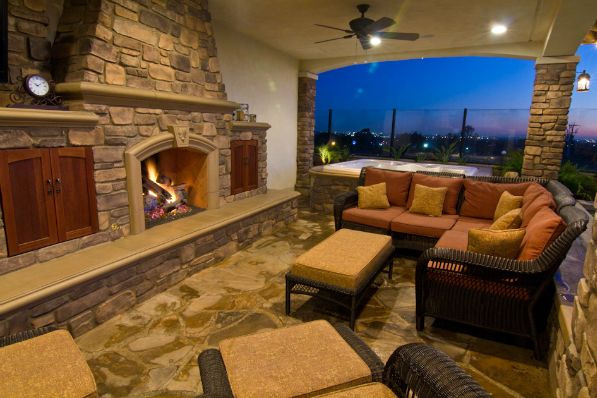How many people are in the room? Based on the image, there are no people present in the room. It appears to be a comfortable, well-furnished outdoor patio with a lit fireplace, seating arrangements, and a pleasant view. 